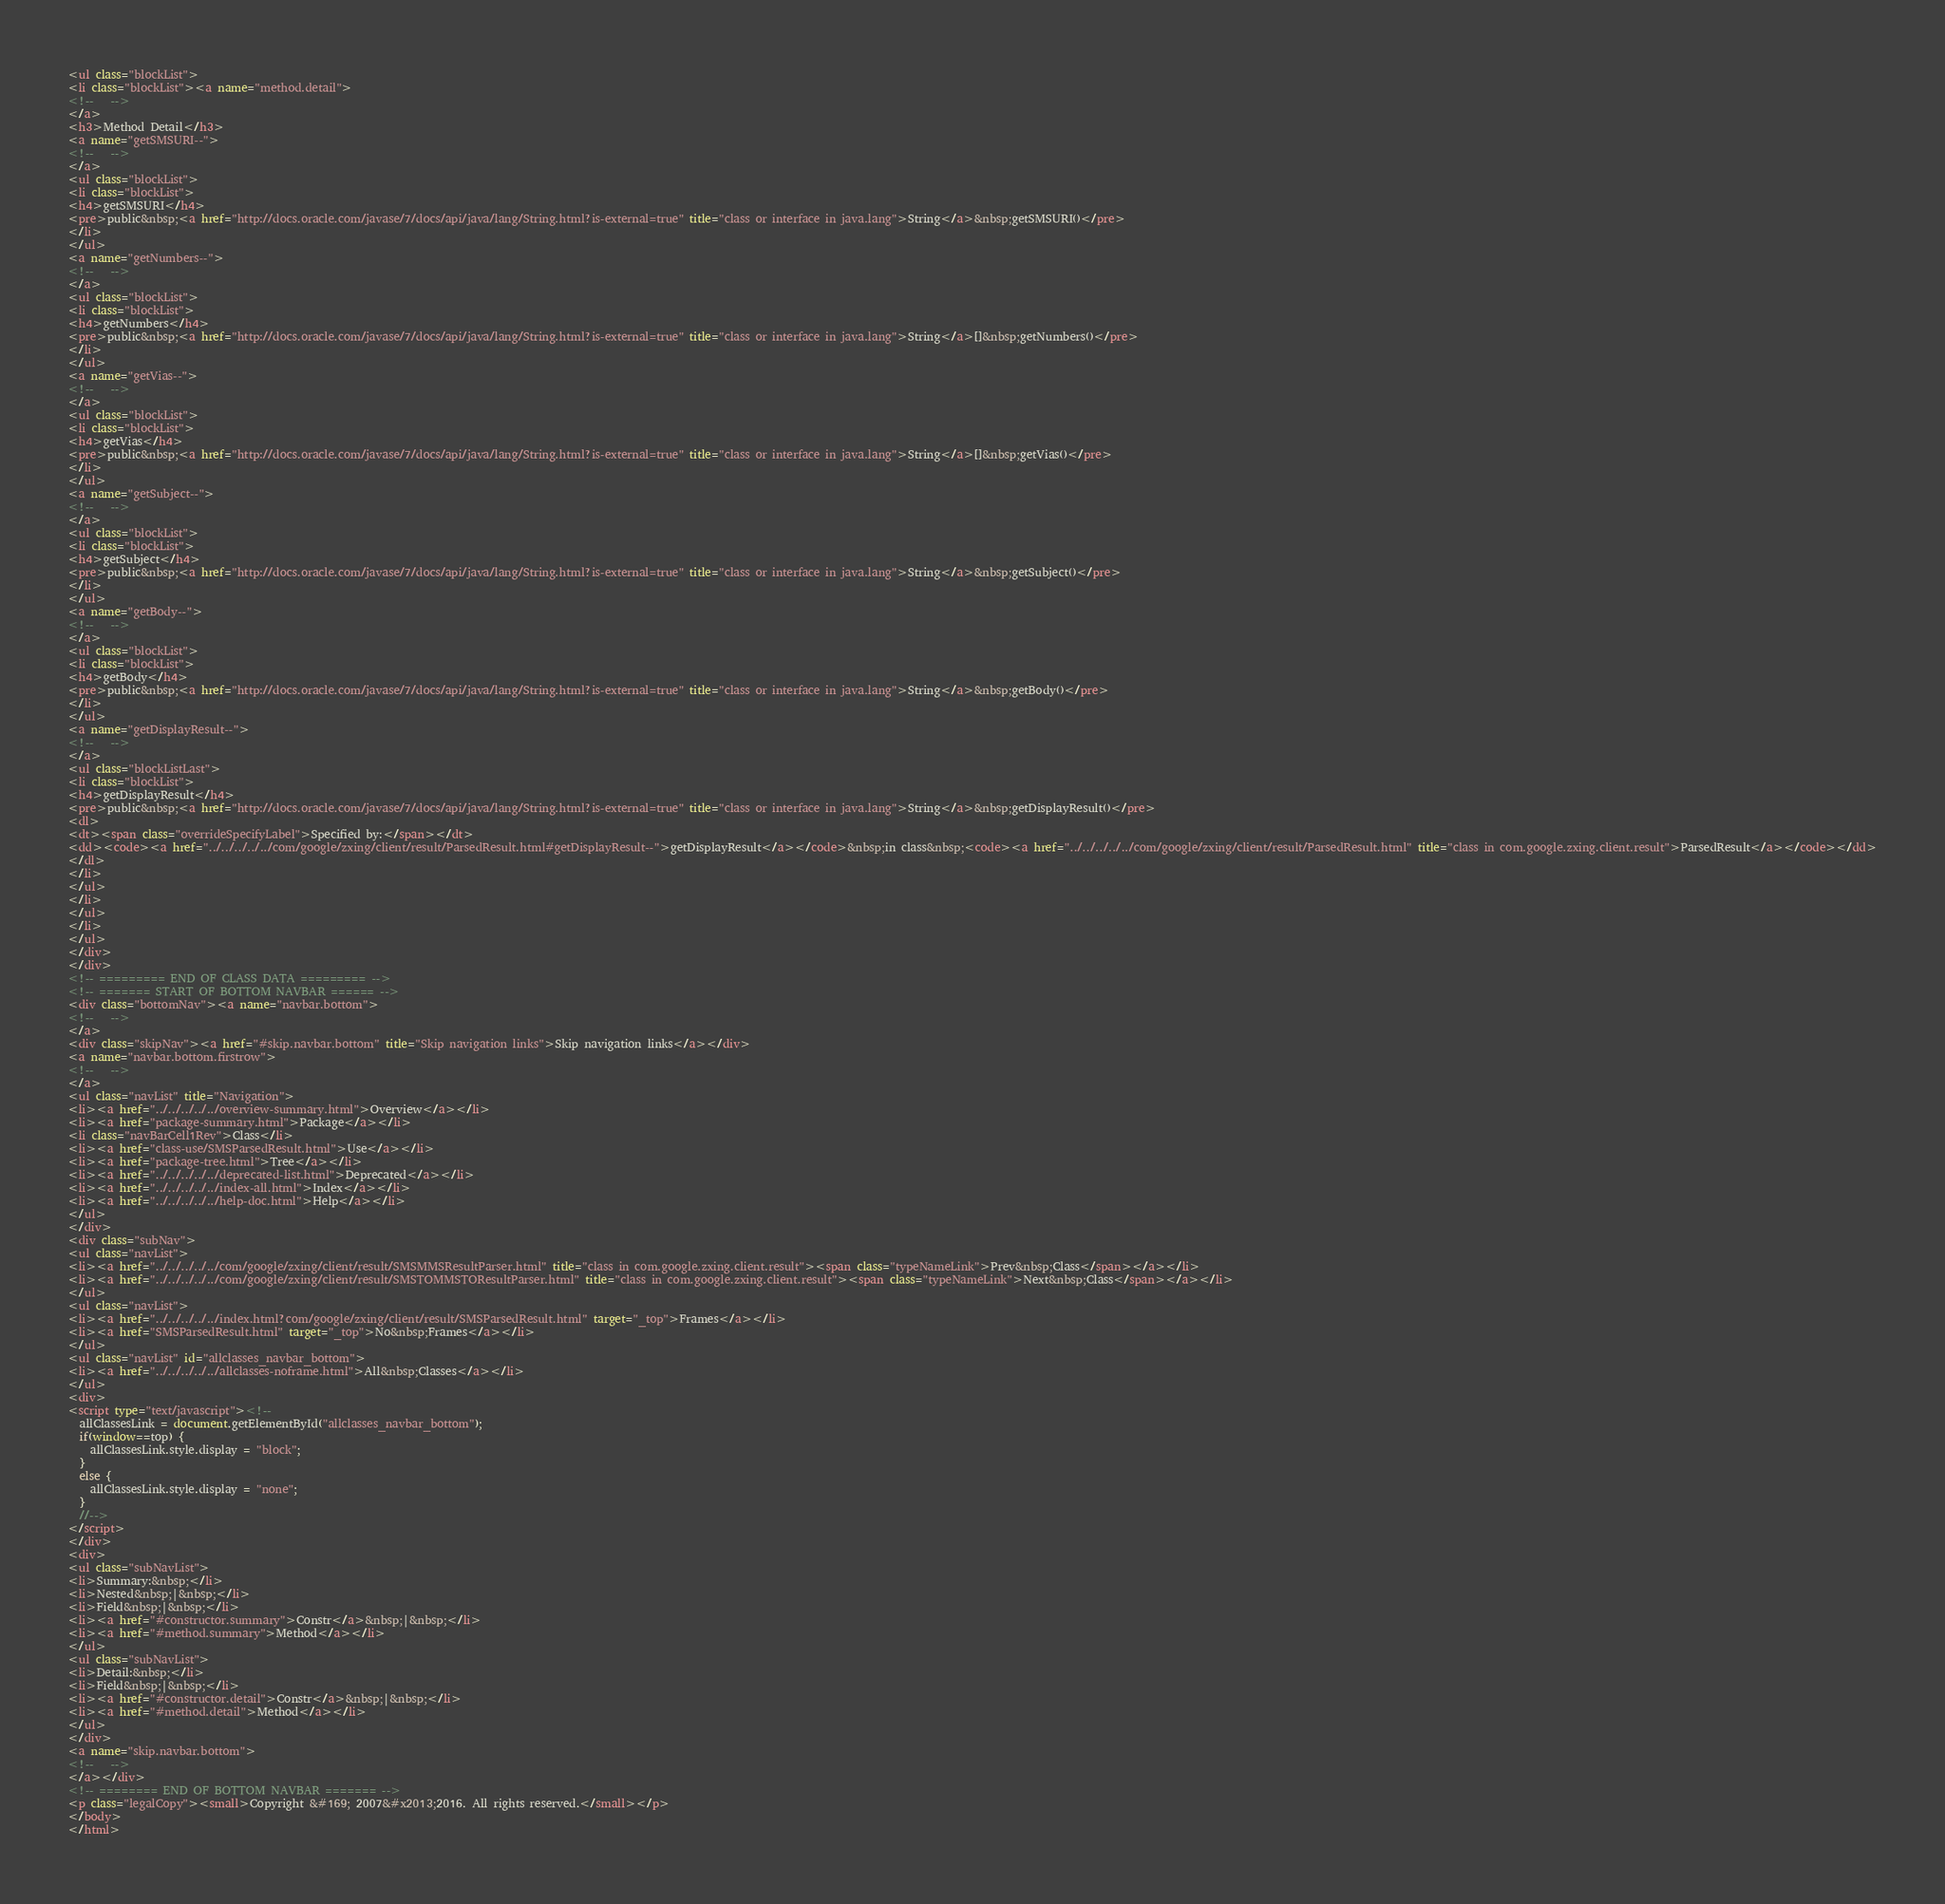Convert code to text. <code><loc_0><loc_0><loc_500><loc_500><_HTML_><ul class="blockList">
<li class="blockList"><a name="method.detail">
<!--   -->
</a>
<h3>Method Detail</h3>
<a name="getSMSURI--">
<!--   -->
</a>
<ul class="blockList">
<li class="blockList">
<h4>getSMSURI</h4>
<pre>public&nbsp;<a href="http://docs.oracle.com/javase/7/docs/api/java/lang/String.html?is-external=true" title="class or interface in java.lang">String</a>&nbsp;getSMSURI()</pre>
</li>
</ul>
<a name="getNumbers--">
<!--   -->
</a>
<ul class="blockList">
<li class="blockList">
<h4>getNumbers</h4>
<pre>public&nbsp;<a href="http://docs.oracle.com/javase/7/docs/api/java/lang/String.html?is-external=true" title="class or interface in java.lang">String</a>[]&nbsp;getNumbers()</pre>
</li>
</ul>
<a name="getVias--">
<!--   -->
</a>
<ul class="blockList">
<li class="blockList">
<h4>getVias</h4>
<pre>public&nbsp;<a href="http://docs.oracle.com/javase/7/docs/api/java/lang/String.html?is-external=true" title="class or interface in java.lang">String</a>[]&nbsp;getVias()</pre>
</li>
</ul>
<a name="getSubject--">
<!--   -->
</a>
<ul class="blockList">
<li class="blockList">
<h4>getSubject</h4>
<pre>public&nbsp;<a href="http://docs.oracle.com/javase/7/docs/api/java/lang/String.html?is-external=true" title="class or interface in java.lang">String</a>&nbsp;getSubject()</pre>
</li>
</ul>
<a name="getBody--">
<!--   -->
</a>
<ul class="blockList">
<li class="blockList">
<h4>getBody</h4>
<pre>public&nbsp;<a href="http://docs.oracle.com/javase/7/docs/api/java/lang/String.html?is-external=true" title="class or interface in java.lang">String</a>&nbsp;getBody()</pre>
</li>
</ul>
<a name="getDisplayResult--">
<!--   -->
</a>
<ul class="blockListLast">
<li class="blockList">
<h4>getDisplayResult</h4>
<pre>public&nbsp;<a href="http://docs.oracle.com/javase/7/docs/api/java/lang/String.html?is-external=true" title="class or interface in java.lang">String</a>&nbsp;getDisplayResult()</pre>
<dl>
<dt><span class="overrideSpecifyLabel">Specified by:</span></dt>
<dd><code><a href="../../../../../com/google/zxing/client/result/ParsedResult.html#getDisplayResult--">getDisplayResult</a></code>&nbsp;in class&nbsp;<code><a href="../../../../../com/google/zxing/client/result/ParsedResult.html" title="class in com.google.zxing.client.result">ParsedResult</a></code></dd>
</dl>
</li>
</ul>
</li>
</ul>
</li>
</ul>
</div>
</div>
<!-- ========= END OF CLASS DATA ========= -->
<!-- ======= START OF BOTTOM NAVBAR ====== -->
<div class="bottomNav"><a name="navbar.bottom">
<!--   -->
</a>
<div class="skipNav"><a href="#skip.navbar.bottom" title="Skip navigation links">Skip navigation links</a></div>
<a name="navbar.bottom.firstrow">
<!--   -->
</a>
<ul class="navList" title="Navigation">
<li><a href="../../../../../overview-summary.html">Overview</a></li>
<li><a href="package-summary.html">Package</a></li>
<li class="navBarCell1Rev">Class</li>
<li><a href="class-use/SMSParsedResult.html">Use</a></li>
<li><a href="package-tree.html">Tree</a></li>
<li><a href="../../../../../deprecated-list.html">Deprecated</a></li>
<li><a href="../../../../../index-all.html">Index</a></li>
<li><a href="../../../../../help-doc.html">Help</a></li>
</ul>
</div>
<div class="subNav">
<ul class="navList">
<li><a href="../../../../../com/google/zxing/client/result/SMSMMSResultParser.html" title="class in com.google.zxing.client.result"><span class="typeNameLink">Prev&nbsp;Class</span></a></li>
<li><a href="../../../../../com/google/zxing/client/result/SMSTOMMSTOResultParser.html" title="class in com.google.zxing.client.result"><span class="typeNameLink">Next&nbsp;Class</span></a></li>
</ul>
<ul class="navList">
<li><a href="../../../../../index.html?com/google/zxing/client/result/SMSParsedResult.html" target="_top">Frames</a></li>
<li><a href="SMSParsedResult.html" target="_top">No&nbsp;Frames</a></li>
</ul>
<ul class="navList" id="allclasses_navbar_bottom">
<li><a href="../../../../../allclasses-noframe.html">All&nbsp;Classes</a></li>
</ul>
<div>
<script type="text/javascript"><!--
  allClassesLink = document.getElementById("allclasses_navbar_bottom");
  if(window==top) {
    allClassesLink.style.display = "block";
  }
  else {
    allClassesLink.style.display = "none";
  }
  //-->
</script>
</div>
<div>
<ul class="subNavList">
<li>Summary:&nbsp;</li>
<li>Nested&nbsp;|&nbsp;</li>
<li>Field&nbsp;|&nbsp;</li>
<li><a href="#constructor.summary">Constr</a>&nbsp;|&nbsp;</li>
<li><a href="#method.summary">Method</a></li>
</ul>
<ul class="subNavList">
<li>Detail:&nbsp;</li>
<li>Field&nbsp;|&nbsp;</li>
<li><a href="#constructor.detail">Constr</a>&nbsp;|&nbsp;</li>
<li><a href="#method.detail">Method</a></li>
</ul>
</div>
<a name="skip.navbar.bottom">
<!--   -->
</a></div>
<!-- ======== END OF BOTTOM NAVBAR ======= -->
<p class="legalCopy"><small>Copyright &#169; 2007&#x2013;2016. All rights reserved.</small></p>
</body>
</html>
</code> 